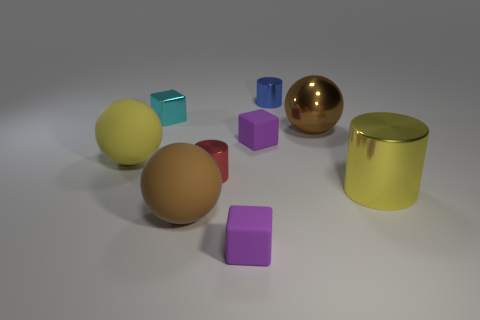There is a small purple rubber block that is in front of the yellow metal object; how many rubber spheres are left of it?
Keep it short and to the point. 2. How many objects are either balls to the left of the tiny cyan metal object or cylinders in front of the blue metal object?
Offer a terse response. 3. What is the material of the big yellow object that is the same shape as the big brown rubber object?
Provide a short and direct response. Rubber. What number of things are either large yellow things that are on the right side of the red cylinder or small blue shiny cylinders?
Offer a terse response. 2. There is a big yellow thing that is made of the same material as the cyan thing; what is its shape?
Offer a very short reply. Cylinder. How many brown rubber objects are the same shape as the brown shiny thing?
Ensure brevity in your answer.  1. What is the material of the red cylinder?
Offer a terse response. Metal. Does the large metallic cylinder have the same color as the rubber ball that is behind the red thing?
Make the answer very short. Yes. How many cylinders are either purple things or yellow things?
Your response must be concise. 1. There is a sphere that is behind the yellow matte object; what is its color?
Provide a succinct answer. Brown. 